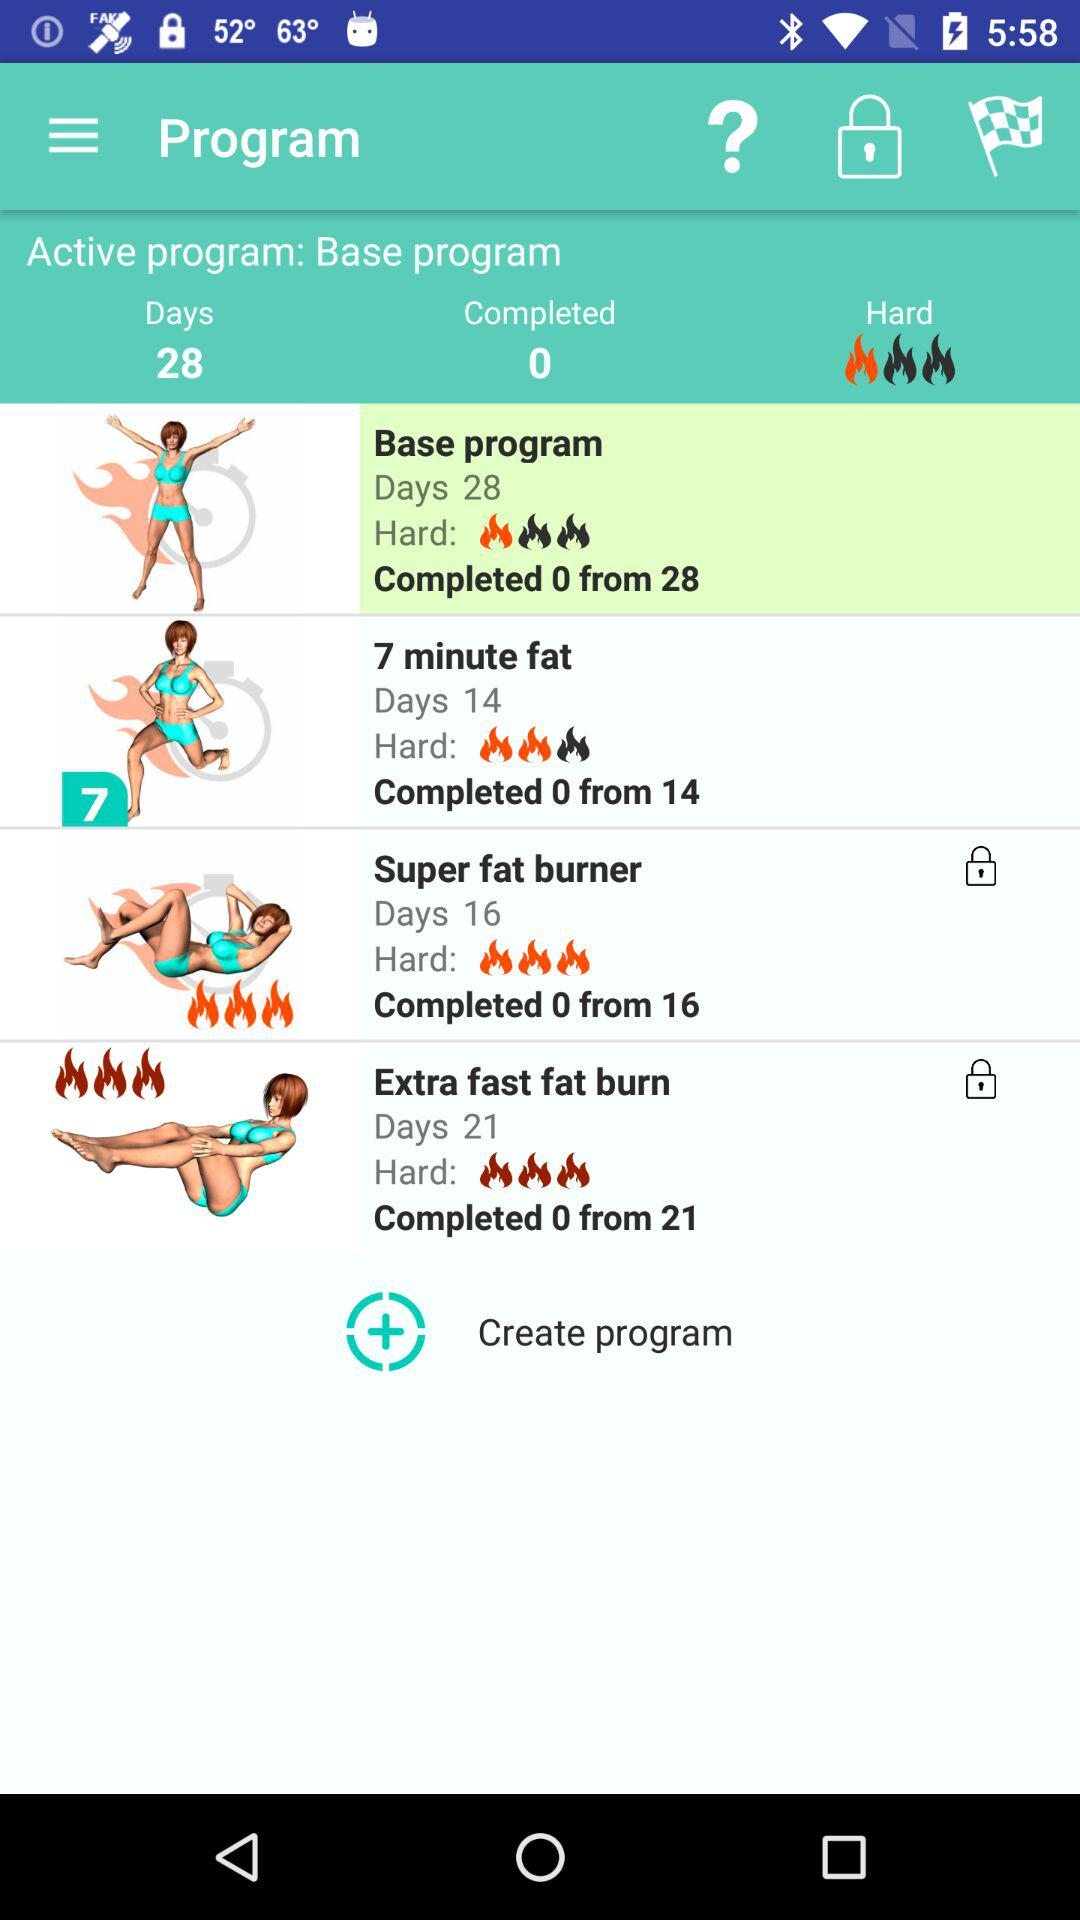How many days are there in the Super fat burner program?
Answer the question using a single word or phrase. 16 